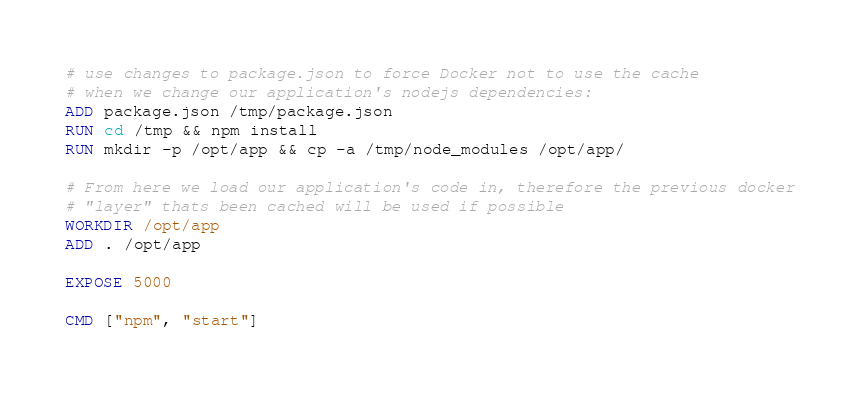<code> <loc_0><loc_0><loc_500><loc_500><_Dockerfile_>
# use changes to package.json to force Docker not to use the cache
# when we change our application's nodejs dependencies:
ADD package.json /tmp/package.json
RUN cd /tmp && npm install
RUN mkdir -p /opt/app && cp -a /tmp/node_modules /opt/app/

# From here we load our application's code in, therefore the previous docker
# "layer" thats been cached will be used if possible
WORKDIR /opt/app
ADD . /opt/app

EXPOSE 5000

CMD ["npm", "start"]
</code> 